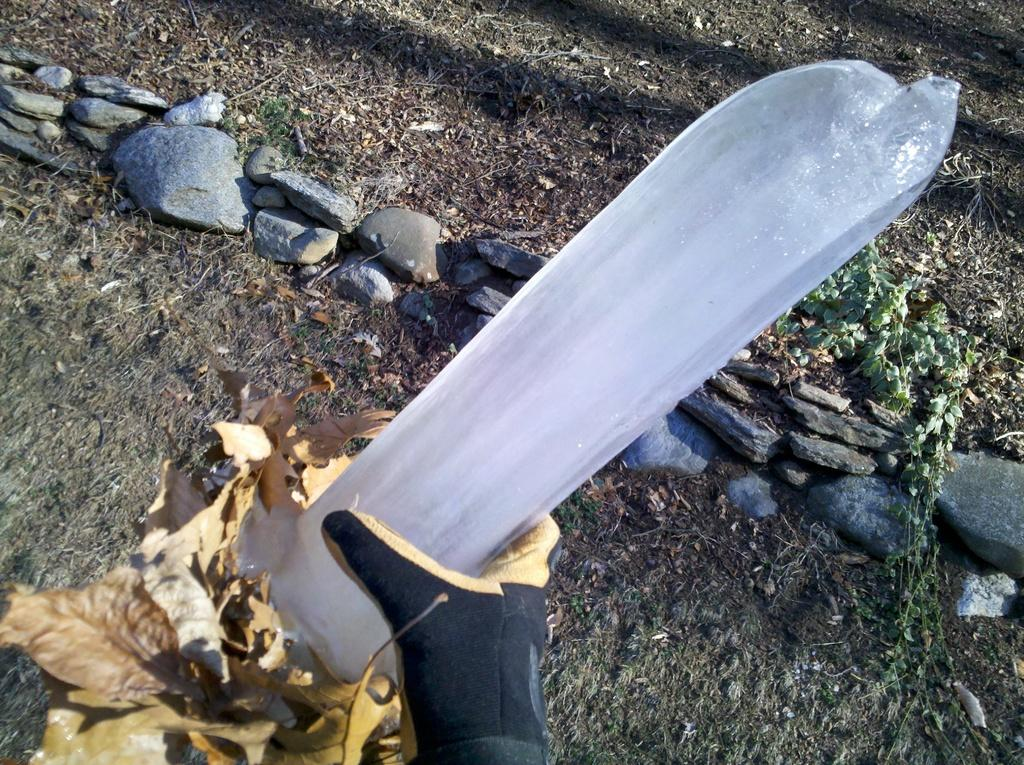What is the main object in the image? There is an ice block in the image. Who is holding the ice block? A person is holding the ice block. What protective gear is the person wearing? The person is wearing gloves. What can be seen on the ground in the image? There are leaves, rocks, and plants on the ground in the image. Where is the cave located in the image? There is no cave present in the image. What is the person using to carry the ice block in the image? The person is holding the ice block directly, and there is no tray or other object being used to carry it. 